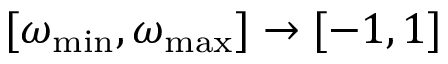Convert formula to latex. <formula><loc_0><loc_0><loc_500><loc_500>[ \omega _ { \min } , \omega _ { \max } ] \rightarrow [ - 1 , 1 ]</formula> 